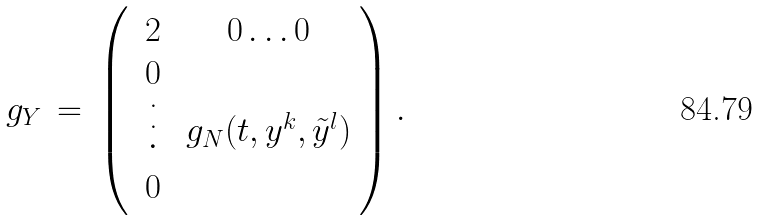Convert formula to latex. <formula><loc_0><loc_0><loc_500><loc_500>g _ { Y } \, = \, \left ( \begin{array} { c c } 2 & 0 \, . \, . \, . \, 0 \\ \begin{array} { c } 0 \\ \stackrel { \cdot } { \stackrel { \cdot } { \cdot } } \\ 0 \end{array} & g _ { N } ( t , y ^ { k } , \tilde { y } ^ { l } ) \end{array} \right ) .</formula> 